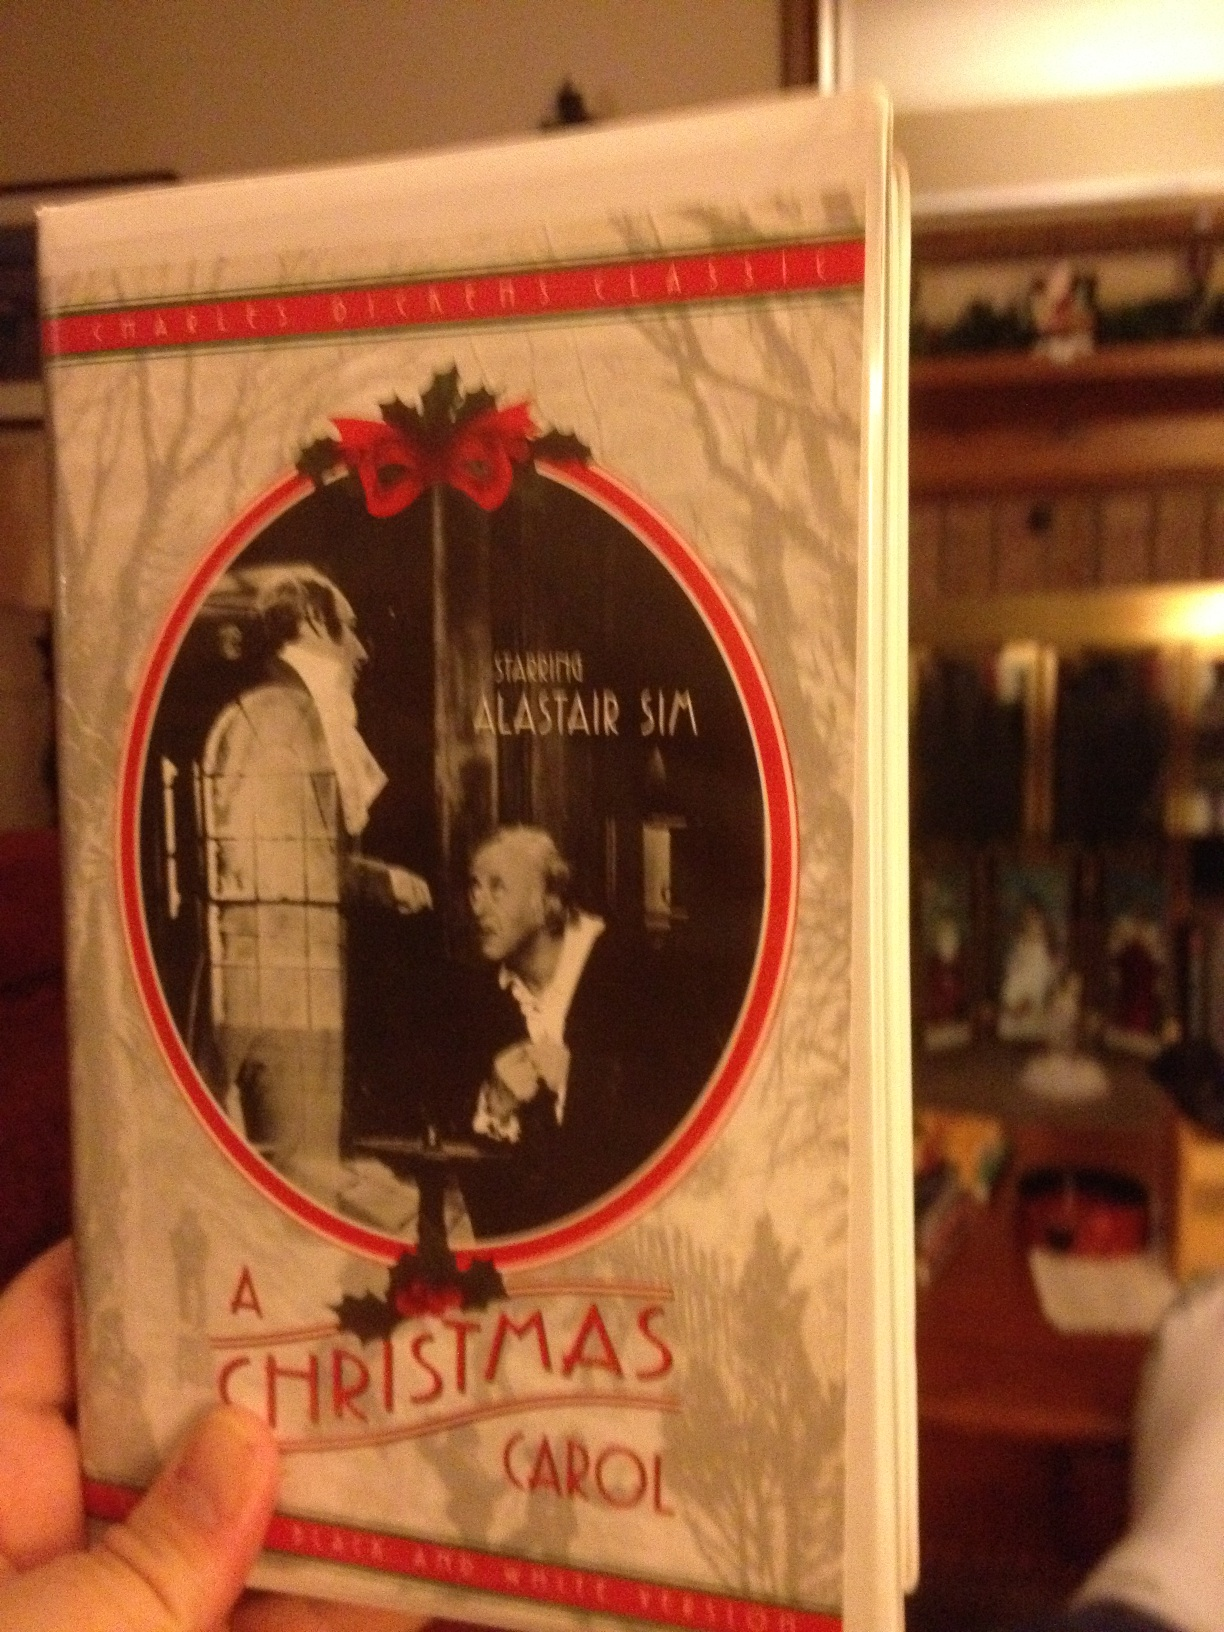What is this? This is a DVD cover for the classic film 'A Christmas Carol,' starring Alastair Sim. The film is an adaptation of Charles Dickens' beloved holiday novella, which tells the story of Ebenezer Scrooge and his transformation after encounters with the ghosts of Christmas Past, Present, and Yet to Come. 